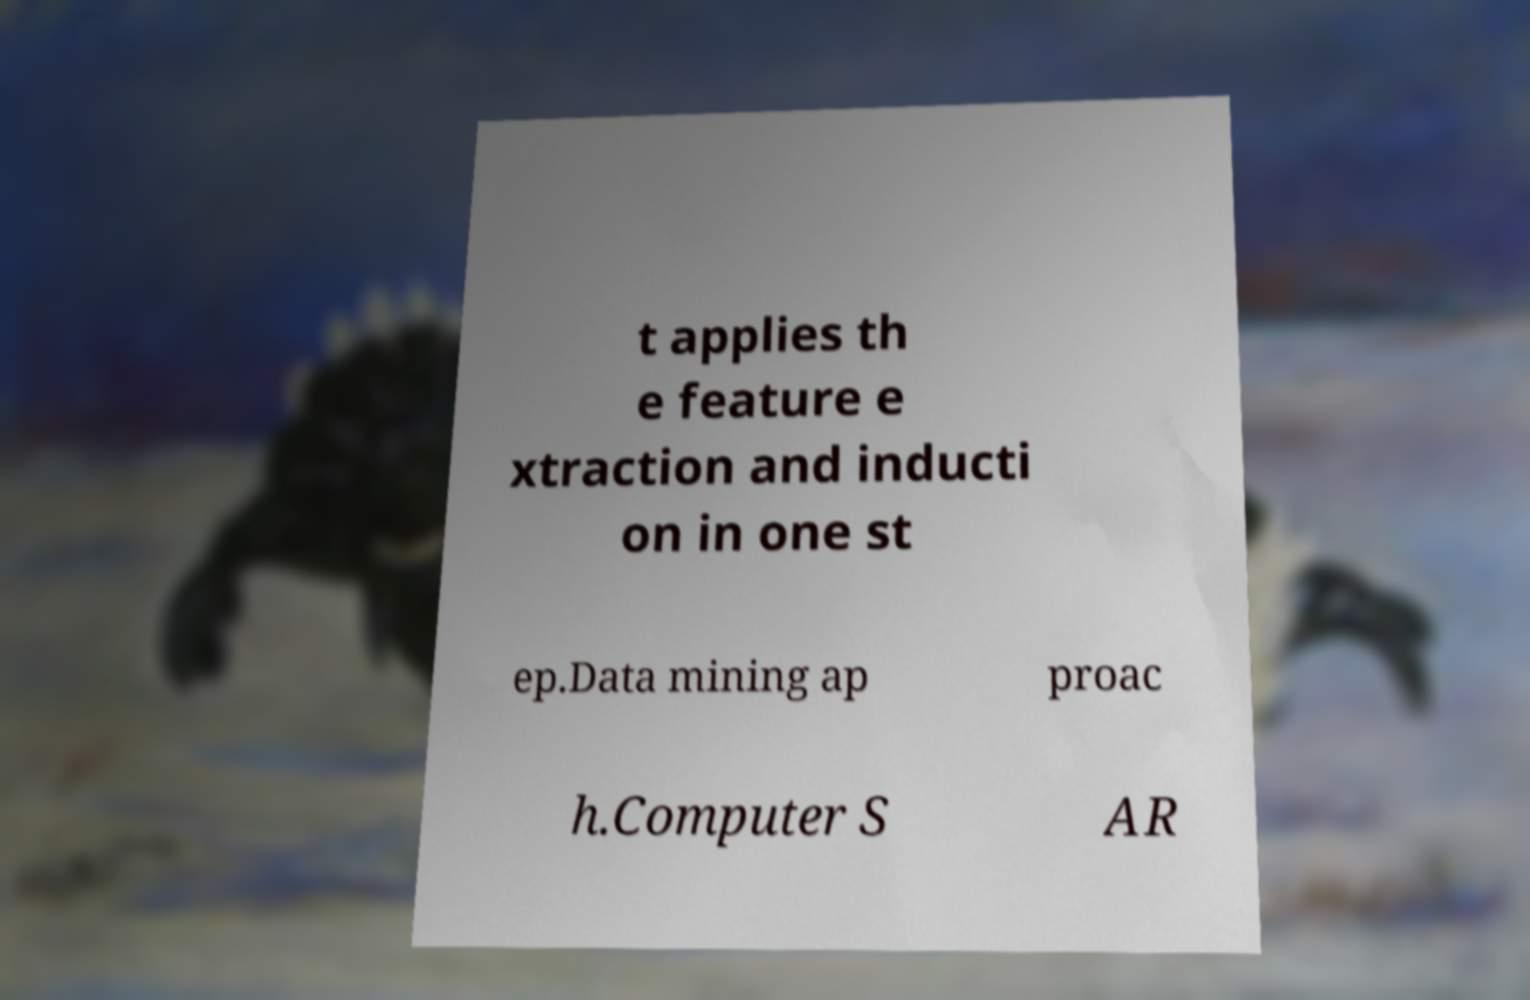There's text embedded in this image that I need extracted. Can you transcribe it verbatim? t applies th e feature e xtraction and inducti on in one st ep.Data mining ap proac h.Computer S AR 